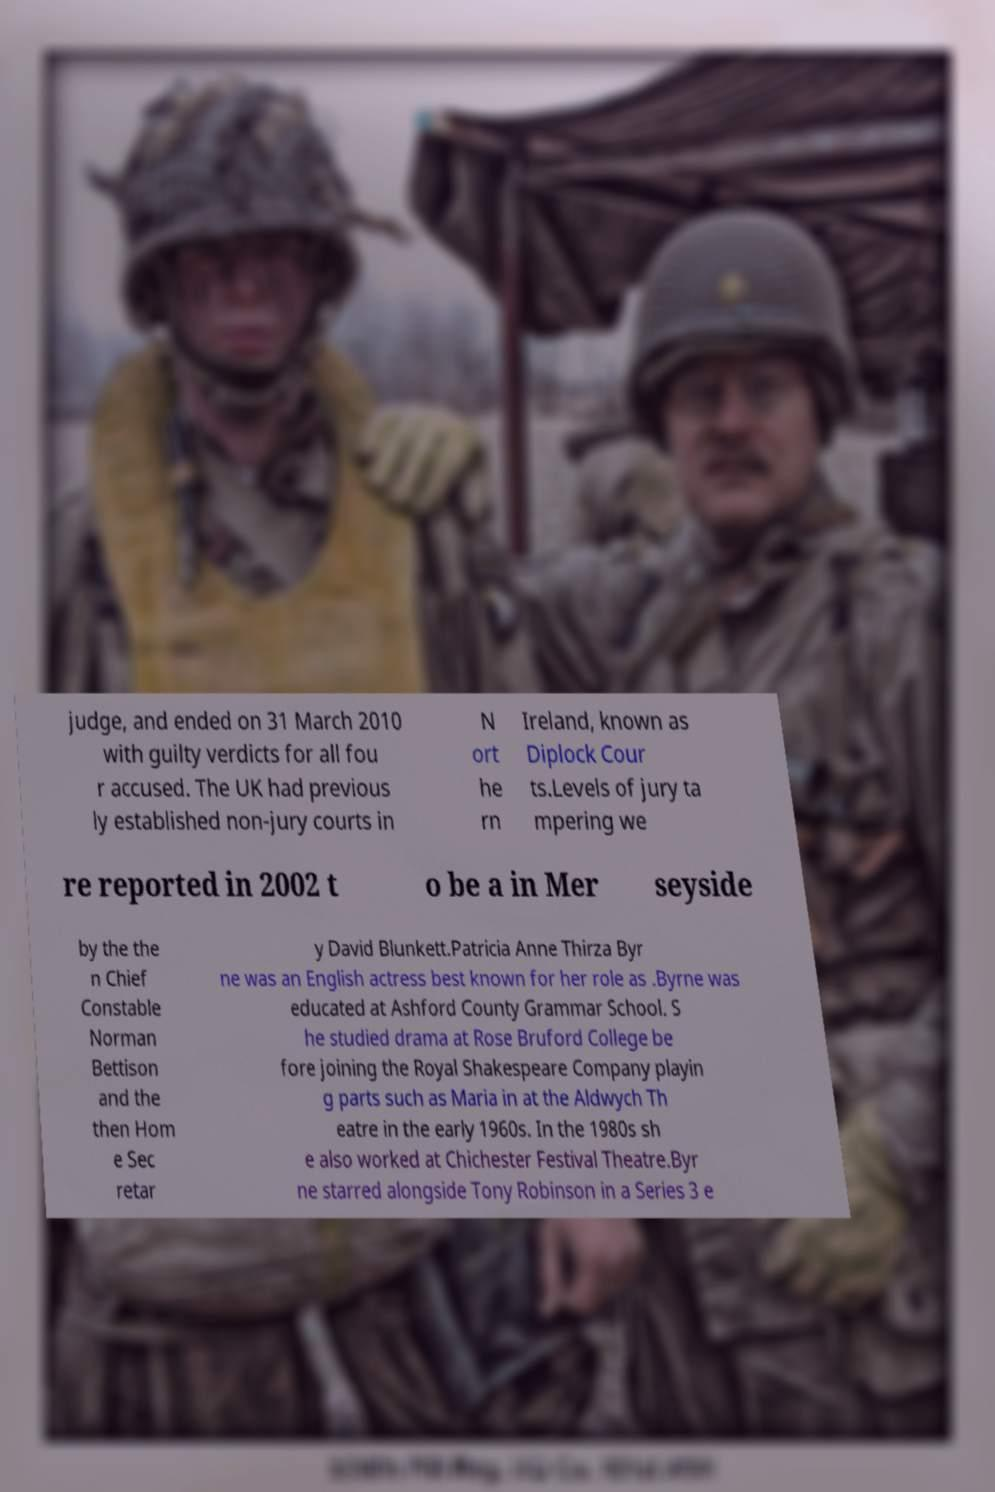Could you extract and type out the text from this image? judge, and ended on 31 March 2010 with guilty verdicts for all fou r accused. The UK had previous ly established non-jury courts in N ort he rn Ireland, known as Diplock Cour ts.Levels of jury ta mpering we re reported in 2002 t o be a in Mer seyside by the the n Chief Constable Norman Bettison and the then Hom e Sec retar y David Blunkett.Patricia Anne Thirza Byr ne was an English actress best known for her role as .Byrne was educated at Ashford County Grammar School. S he studied drama at Rose Bruford College be fore joining the Royal Shakespeare Company playin g parts such as Maria in at the Aldwych Th eatre in the early 1960s. In the 1980s sh e also worked at Chichester Festival Theatre.Byr ne starred alongside Tony Robinson in a Series 3 e 